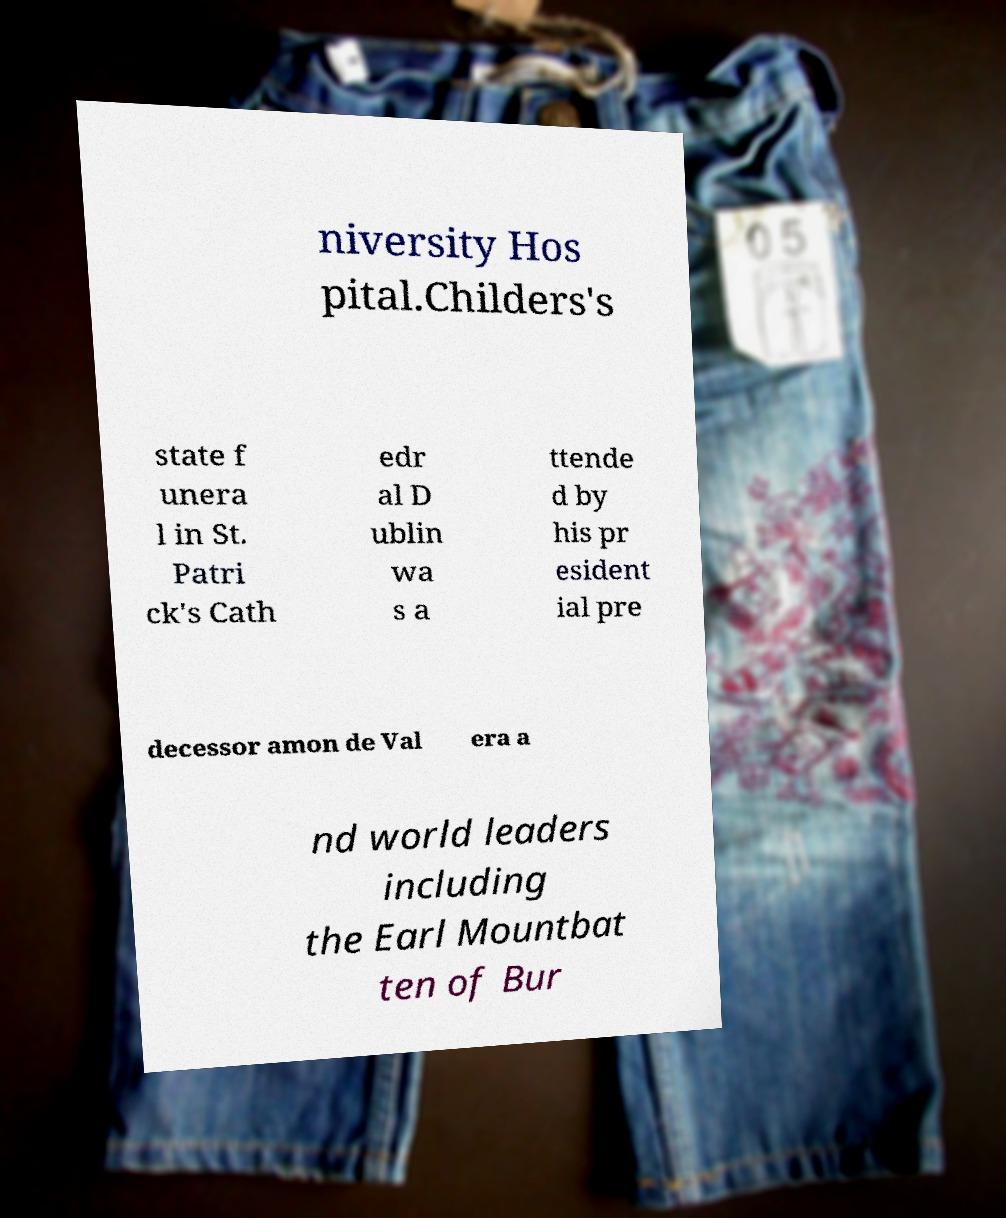Could you extract and type out the text from this image? niversity Hos pital.Childers's state f unera l in St. Patri ck's Cath edr al D ublin wa s a ttende d by his pr esident ial pre decessor amon de Val era a nd world leaders including the Earl Mountbat ten of Bur 